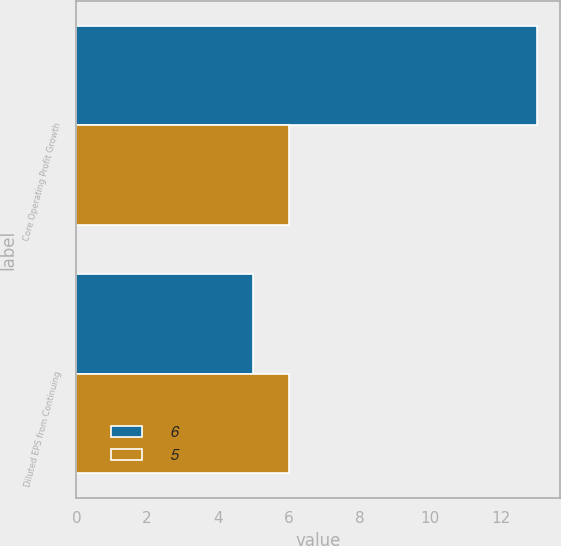Convert chart to OTSL. <chart><loc_0><loc_0><loc_500><loc_500><stacked_bar_chart><ecel><fcel>Core Operating Profit Growth<fcel>Diluted EPS from Continuing<nl><fcel>6<fcel>13<fcel>5<nl><fcel>5<fcel>6<fcel>6<nl></chart> 